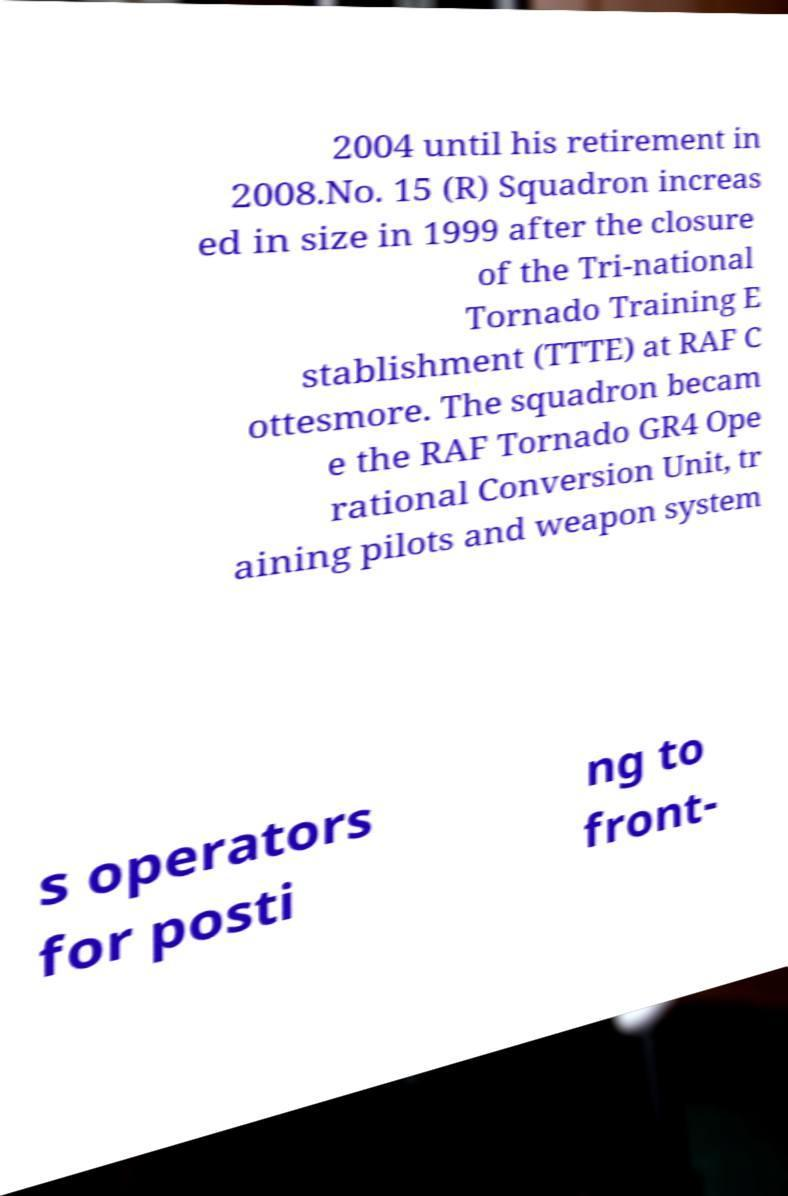Could you extract and type out the text from this image? 2004 until his retirement in 2008.No. 15 (R) Squadron increas ed in size in 1999 after the closure of the Tri-national Tornado Training E stablishment (TTTE) at RAF C ottesmore. The squadron becam e the RAF Tornado GR4 Ope rational Conversion Unit, tr aining pilots and weapon system s operators for posti ng to front- 